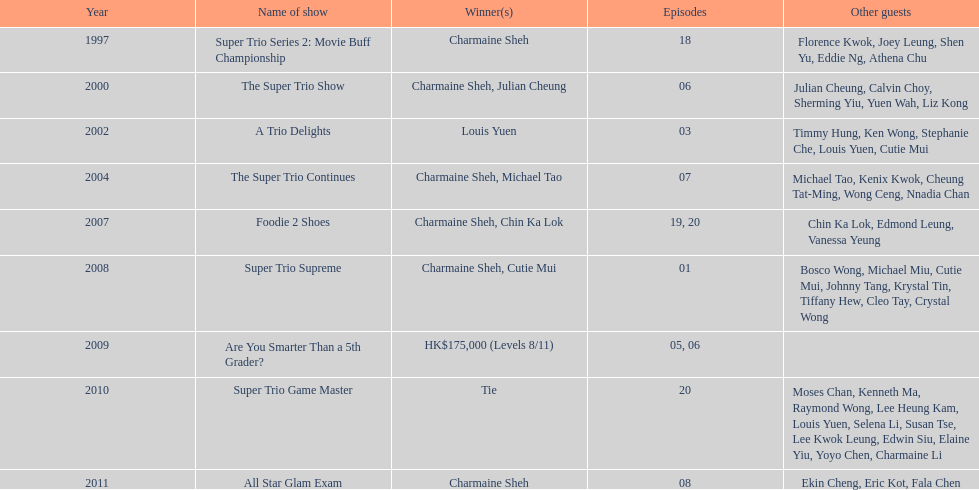How long has it been since chermaine sheh first appeared on a variety show? 17 years. 